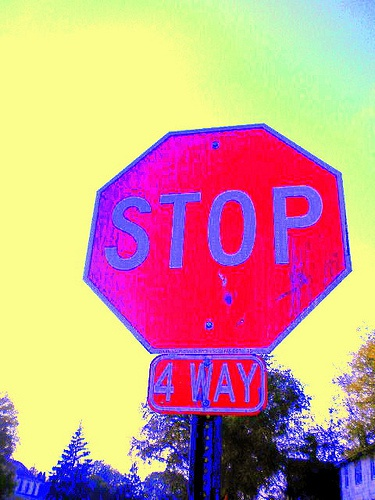Describe the objects in this image and their specific colors. I can see a stop sign in lightgreen, red, blue, and magenta tones in this image. 